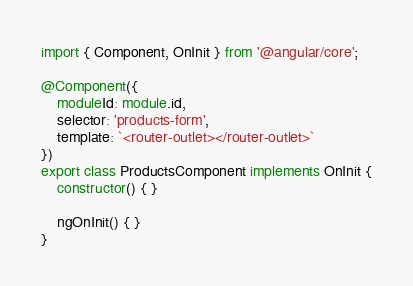<code> <loc_0><loc_0><loc_500><loc_500><_TypeScript_>import { Component, OnInit } from '@angular/core';

@Component({
    moduleId: module.id,
    selector: 'products-form',
    template: `<router-outlet></router-outlet>`
})
export class ProductsComponent implements OnInit {
    constructor() { }

    ngOnInit() { }
}</code> 